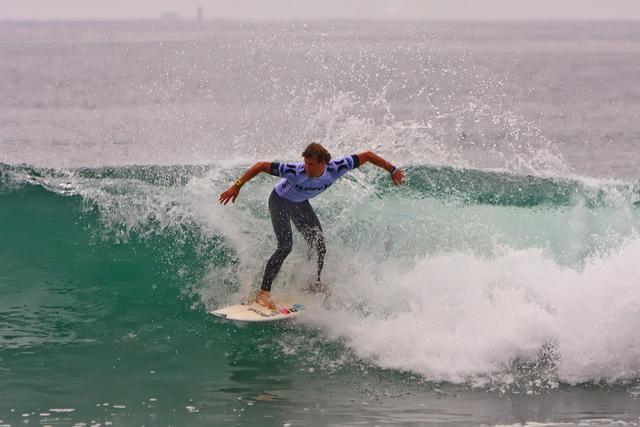How many people can be seen?
Give a very brief answer. 1. How many purple trains are there?
Give a very brief answer. 0. 